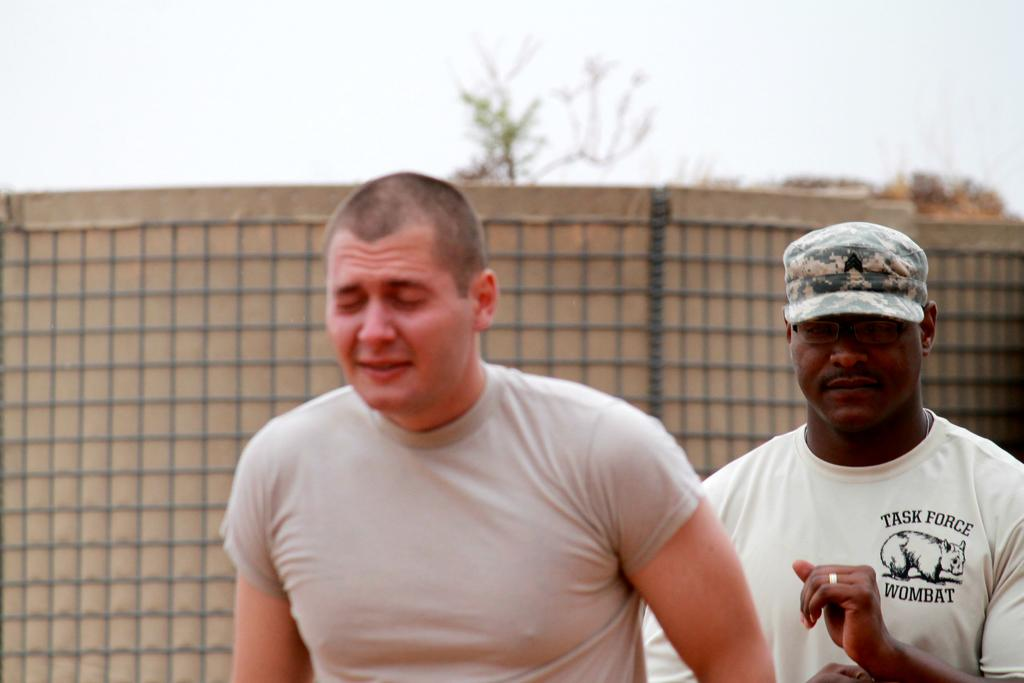What is the main subject in the foreground of the picture? There is a person in the foreground of the picture. Can you describe the person on the right side of the picture? There is a person wearing a cap on the right side of the picture. What can be seen in the background of the picture? There are trees, a wall, sky, and a net visible in the background of the picture. What type of pencil can be seen in the person's hand in the image? There is no pencil visible in the person's hand in the image. Can you describe the bee buzzing around the trees in the background? There are no bees present in the image; only trees, a wall, sky, and a net are visible in the background. 